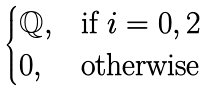Convert formula to latex. <formula><loc_0><loc_0><loc_500><loc_500>\begin{cases} \mathbb { Q } , & \text {if $i=0,2$} \\ 0 , & \text {otherwise} \end{cases}</formula> 